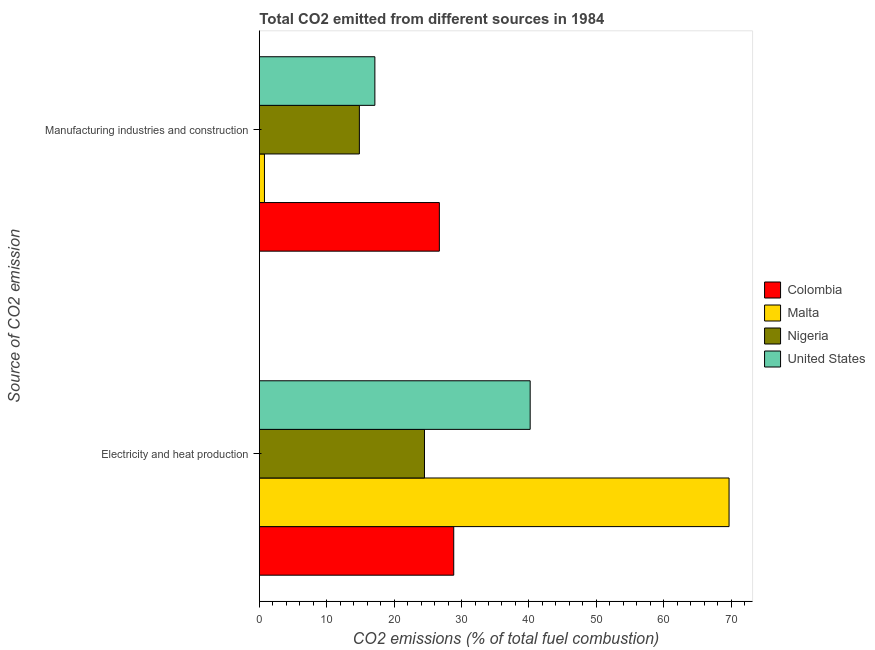How many groups of bars are there?
Keep it short and to the point. 2. How many bars are there on the 2nd tick from the top?
Offer a very short reply. 4. How many bars are there on the 1st tick from the bottom?
Ensure brevity in your answer.  4. What is the label of the 2nd group of bars from the top?
Ensure brevity in your answer.  Electricity and heat production. What is the co2 emissions due to electricity and heat production in United States?
Offer a very short reply. 40.19. Across all countries, what is the maximum co2 emissions due to manufacturing industries?
Your answer should be very brief. 26.71. Across all countries, what is the minimum co2 emissions due to electricity and heat production?
Your answer should be compact. 24.5. In which country was the co2 emissions due to manufacturing industries maximum?
Make the answer very short. Colombia. In which country was the co2 emissions due to manufacturing industries minimum?
Offer a terse response. Malta. What is the total co2 emissions due to manufacturing industries in the graph?
Your answer should be compact. 59.45. What is the difference between the co2 emissions due to electricity and heat production in Nigeria and that in Colombia?
Offer a very short reply. -4.34. What is the difference between the co2 emissions due to electricity and heat production in Malta and the co2 emissions due to manufacturing industries in Colombia?
Keep it short and to the point. 42.99. What is the average co2 emissions due to electricity and heat production per country?
Give a very brief answer. 40.81. What is the difference between the co2 emissions due to manufacturing industries and co2 emissions due to electricity and heat production in Malta?
Your response must be concise. -68.94. In how many countries, is the co2 emissions due to manufacturing industries greater than 20 %?
Make the answer very short. 1. What is the ratio of the co2 emissions due to electricity and heat production in Colombia to that in Nigeria?
Offer a very short reply. 1.18. In how many countries, is the co2 emissions due to electricity and heat production greater than the average co2 emissions due to electricity and heat production taken over all countries?
Keep it short and to the point. 1. What does the 2nd bar from the top in Electricity and heat production represents?
Your answer should be very brief. Nigeria. What does the 2nd bar from the bottom in Manufacturing industries and construction represents?
Offer a terse response. Malta. Are all the bars in the graph horizontal?
Ensure brevity in your answer.  Yes. How many countries are there in the graph?
Offer a terse response. 4. Are the values on the major ticks of X-axis written in scientific E-notation?
Your answer should be very brief. No. Does the graph contain grids?
Offer a terse response. No. Where does the legend appear in the graph?
Your answer should be very brief. Center right. What is the title of the graph?
Your answer should be very brief. Total CO2 emitted from different sources in 1984. What is the label or title of the X-axis?
Your answer should be very brief. CO2 emissions (% of total fuel combustion). What is the label or title of the Y-axis?
Provide a short and direct response. Source of CO2 emission. What is the CO2 emissions (% of total fuel combustion) of Colombia in Electricity and heat production?
Offer a very short reply. 28.84. What is the CO2 emissions (% of total fuel combustion) of Malta in Electricity and heat production?
Give a very brief answer. 69.7. What is the CO2 emissions (% of total fuel combustion) in Nigeria in Electricity and heat production?
Keep it short and to the point. 24.5. What is the CO2 emissions (% of total fuel combustion) of United States in Electricity and heat production?
Provide a short and direct response. 40.19. What is the CO2 emissions (% of total fuel combustion) of Colombia in Manufacturing industries and construction?
Provide a short and direct response. 26.71. What is the CO2 emissions (% of total fuel combustion) in Malta in Manufacturing industries and construction?
Provide a succinct answer. 0.76. What is the CO2 emissions (% of total fuel combustion) of Nigeria in Manufacturing industries and construction?
Your response must be concise. 14.84. What is the CO2 emissions (% of total fuel combustion) of United States in Manufacturing industries and construction?
Give a very brief answer. 17.14. Across all Source of CO2 emission, what is the maximum CO2 emissions (% of total fuel combustion) in Colombia?
Provide a succinct answer. 28.84. Across all Source of CO2 emission, what is the maximum CO2 emissions (% of total fuel combustion) in Malta?
Make the answer very short. 69.7. Across all Source of CO2 emission, what is the maximum CO2 emissions (% of total fuel combustion) of Nigeria?
Offer a terse response. 24.5. Across all Source of CO2 emission, what is the maximum CO2 emissions (% of total fuel combustion) of United States?
Keep it short and to the point. 40.19. Across all Source of CO2 emission, what is the minimum CO2 emissions (% of total fuel combustion) in Colombia?
Provide a succinct answer. 26.71. Across all Source of CO2 emission, what is the minimum CO2 emissions (% of total fuel combustion) of Malta?
Your answer should be very brief. 0.76. Across all Source of CO2 emission, what is the minimum CO2 emissions (% of total fuel combustion) of Nigeria?
Provide a succinct answer. 14.84. Across all Source of CO2 emission, what is the minimum CO2 emissions (% of total fuel combustion) of United States?
Ensure brevity in your answer.  17.14. What is the total CO2 emissions (% of total fuel combustion) in Colombia in the graph?
Your answer should be compact. 55.55. What is the total CO2 emissions (% of total fuel combustion) in Malta in the graph?
Give a very brief answer. 70.45. What is the total CO2 emissions (% of total fuel combustion) of Nigeria in the graph?
Your answer should be compact. 39.34. What is the total CO2 emissions (% of total fuel combustion) in United States in the graph?
Your answer should be very brief. 57.33. What is the difference between the CO2 emissions (% of total fuel combustion) of Colombia in Electricity and heat production and that in Manufacturing industries and construction?
Offer a very short reply. 2.13. What is the difference between the CO2 emissions (% of total fuel combustion) of Malta in Electricity and heat production and that in Manufacturing industries and construction?
Keep it short and to the point. 68.94. What is the difference between the CO2 emissions (% of total fuel combustion) in Nigeria in Electricity and heat production and that in Manufacturing industries and construction?
Keep it short and to the point. 9.66. What is the difference between the CO2 emissions (% of total fuel combustion) of United States in Electricity and heat production and that in Manufacturing industries and construction?
Give a very brief answer. 23.04. What is the difference between the CO2 emissions (% of total fuel combustion) of Colombia in Electricity and heat production and the CO2 emissions (% of total fuel combustion) of Malta in Manufacturing industries and construction?
Your answer should be compact. 28.08. What is the difference between the CO2 emissions (% of total fuel combustion) of Colombia in Electricity and heat production and the CO2 emissions (% of total fuel combustion) of Nigeria in Manufacturing industries and construction?
Provide a short and direct response. 14. What is the difference between the CO2 emissions (% of total fuel combustion) in Colombia in Electricity and heat production and the CO2 emissions (% of total fuel combustion) in United States in Manufacturing industries and construction?
Ensure brevity in your answer.  11.7. What is the difference between the CO2 emissions (% of total fuel combustion) in Malta in Electricity and heat production and the CO2 emissions (% of total fuel combustion) in Nigeria in Manufacturing industries and construction?
Your answer should be very brief. 54.85. What is the difference between the CO2 emissions (% of total fuel combustion) of Malta in Electricity and heat production and the CO2 emissions (% of total fuel combustion) of United States in Manufacturing industries and construction?
Make the answer very short. 52.55. What is the difference between the CO2 emissions (% of total fuel combustion) of Nigeria in Electricity and heat production and the CO2 emissions (% of total fuel combustion) of United States in Manufacturing industries and construction?
Provide a succinct answer. 7.36. What is the average CO2 emissions (% of total fuel combustion) of Colombia per Source of CO2 emission?
Provide a short and direct response. 27.78. What is the average CO2 emissions (% of total fuel combustion) of Malta per Source of CO2 emission?
Ensure brevity in your answer.  35.23. What is the average CO2 emissions (% of total fuel combustion) of Nigeria per Source of CO2 emission?
Offer a terse response. 19.67. What is the average CO2 emissions (% of total fuel combustion) of United States per Source of CO2 emission?
Your answer should be compact. 28.66. What is the difference between the CO2 emissions (% of total fuel combustion) of Colombia and CO2 emissions (% of total fuel combustion) of Malta in Electricity and heat production?
Offer a very short reply. -40.85. What is the difference between the CO2 emissions (% of total fuel combustion) in Colombia and CO2 emissions (% of total fuel combustion) in Nigeria in Electricity and heat production?
Offer a very short reply. 4.34. What is the difference between the CO2 emissions (% of total fuel combustion) in Colombia and CO2 emissions (% of total fuel combustion) in United States in Electricity and heat production?
Make the answer very short. -11.34. What is the difference between the CO2 emissions (% of total fuel combustion) in Malta and CO2 emissions (% of total fuel combustion) in Nigeria in Electricity and heat production?
Provide a succinct answer. 45.2. What is the difference between the CO2 emissions (% of total fuel combustion) in Malta and CO2 emissions (% of total fuel combustion) in United States in Electricity and heat production?
Keep it short and to the point. 29.51. What is the difference between the CO2 emissions (% of total fuel combustion) of Nigeria and CO2 emissions (% of total fuel combustion) of United States in Electricity and heat production?
Keep it short and to the point. -15.68. What is the difference between the CO2 emissions (% of total fuel combustion) in Colombia and CO2 emissions (% of total fuel combustion) in Malta in Manufacturing industries and construction?
Offer a terse response. 25.95. What is the difference between the CO2 emissions (% of total fuel combustion) in Colombia and CO2 emissions (% of total fuel combustion) in Nigeria in Manufacturing industries and construction?
Give a very brief answer. 11.87. What is the difference between the CO2 emissions (% of total fuel combustion) in Colombia and CO2 emissions (% of total fuel combustion) in United States in Manufacturing industries and construction?
Keep it short and to the point. 9.57. What is the difference between the CO2 emissions (% of total fuel combustion) in Malta and CO2 emissions (% of total fuel combustion) in Nigeria in Manufacturing industries and construction?
Your answer should be compact. -14.08. What is the difference between the CO2 emissions (% of total fuel combustion) of Malta and CO2 emissions (% of total fuel combustion) of United States in Manufacturing industries and construction?
Offer a terse response. -16.39. What is the difference between the CO2 emissions (% of total fuel combustion) in Nigeria and CO2 emissions (% of total fuel combustion) in United States in Manufacturing industries and construction?
Make the answer very short. -2.3. What is the ratio of the CO2 emissions (% of total fuel combustion) of Colombia in Electricity and heat production to that in Manufacturing industries and construction?
Make the answer very short. 1.08. What is the ratio of the CO2 emissions (% of total fuel combustion) in Malta in Electricity and heat production to that in Manufacturing industries and construction?
Give a very brief answer. 92. What is the ratio of the CO2 emissions (% of total fuel combustion) in Nigeria in Electricity and heat production to that in Manufacturing industries and construction?
Your answer should be compact. 1.65. What is the ratio of the CO2 emissions (% of total fuel combustion) in United States in Electricity and heat production to that in Manufacturing industries and construction?
Offer a terse response. 2.34. What is the difference between the highest and the second highest CO2 emissions (% of total fuel combustion) of Colombia?
Offer a terse response. 2.13. What is the difference between the highest and the second highest CO2 emissions (% of total fuel combustion) in Malta?
Keep it short and to the point. 68.94. What is the difference between the highest and the second highest CO2 emissions (% of total fuel combustion) in Nigeria?
Your answer should be very brief. 9.66. What is the difference between the highest and the second highest CO2 emissions (% of total fuel combustion) of United States?
Ensure brevity in your answer.  23.04. What is the difference between the highest and the lowest CO2 emissions (% of total fuel combustion) in Colombia?
Your answer should be very brief. 2.13. What is the difference between the highest and the lowest CO2 emissions (% of total fuel combustion) of Malta?
Your answer should be compact. 68.94. What is the difference between the highest and the lowest CO2 emissions (% of total fuel combustion) in Nigeria?
Offer a very short reply. 9.66. What is the difference between the highest and the lowest CO2 emissions (% of total fuel combustion) of United States?
Offer a very short reply. 23.04. 